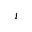<formula> <loc_0><loc_0><loc_500><loc_500>i</formula> 